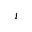<formula> <loc_0><loc_0><loc_500><loc_500>i</formula> 